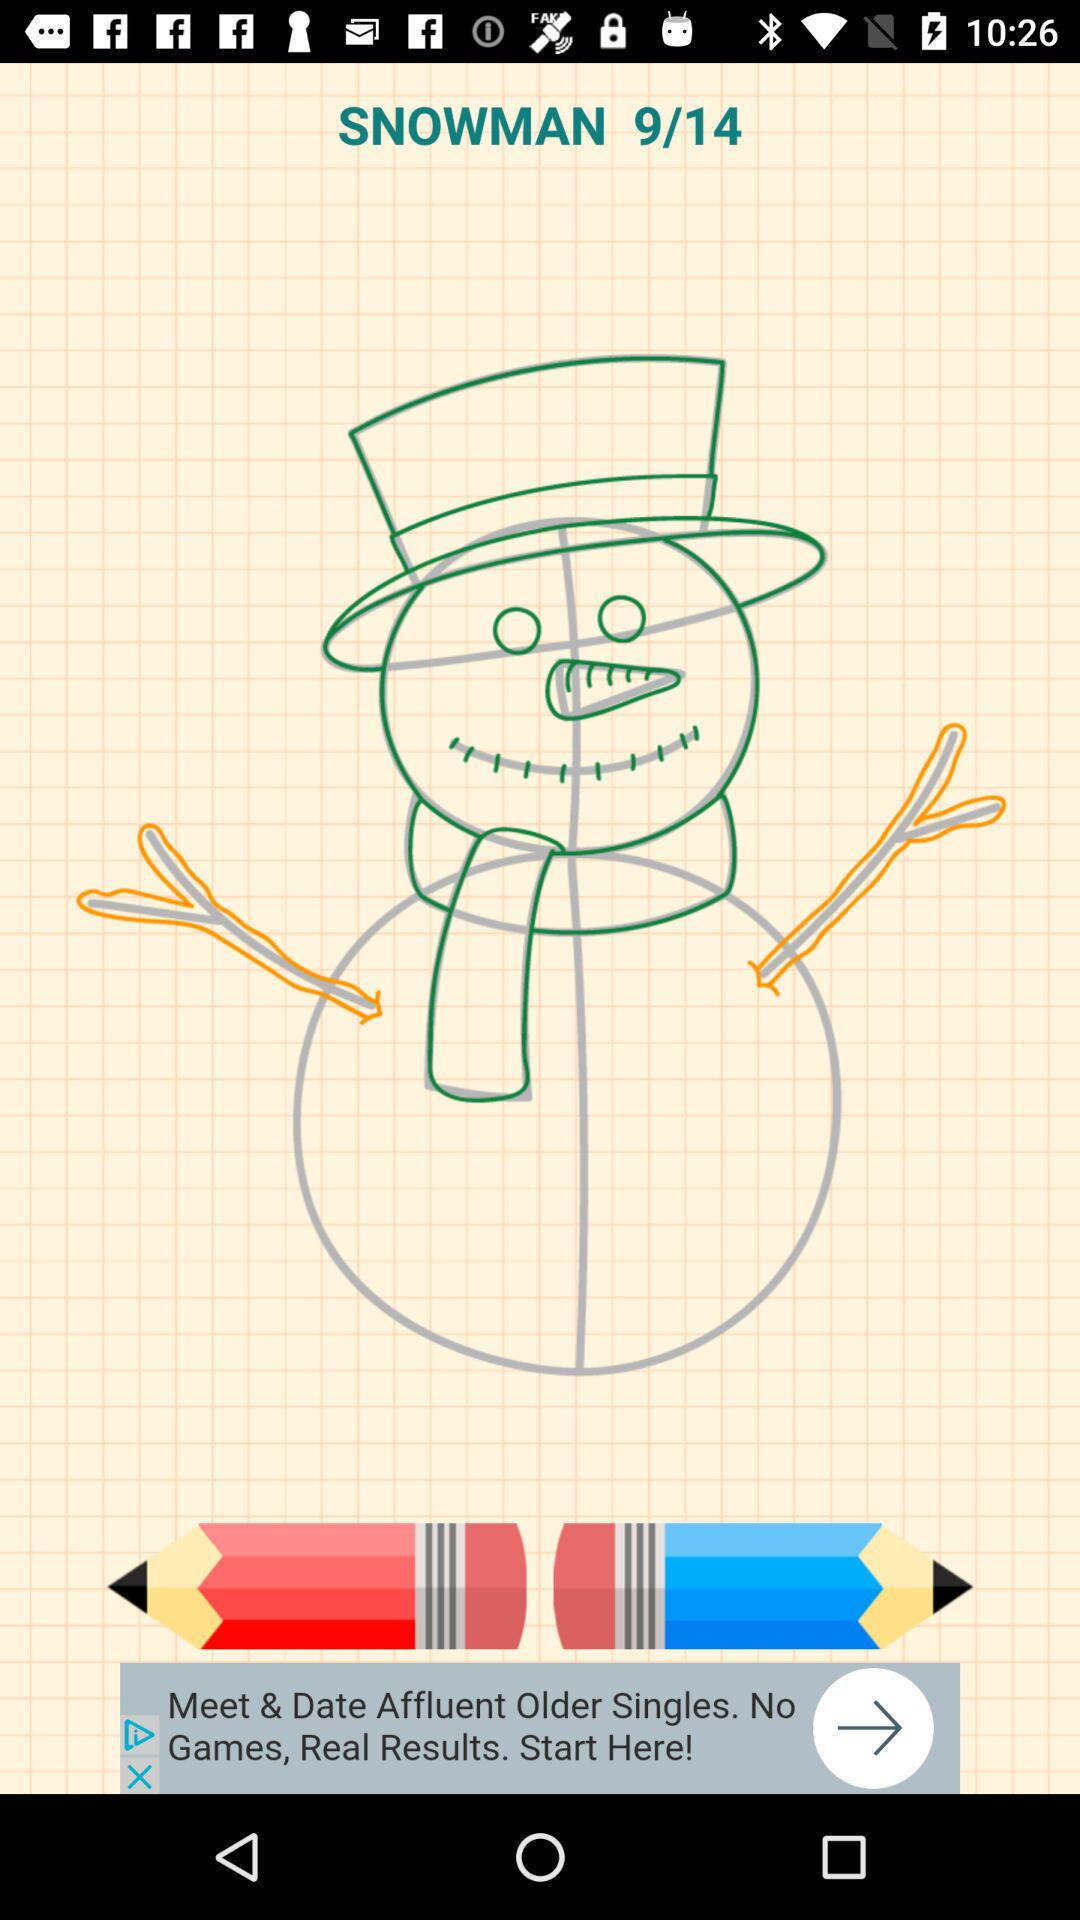How many total pages are there? The total pages are 14. 